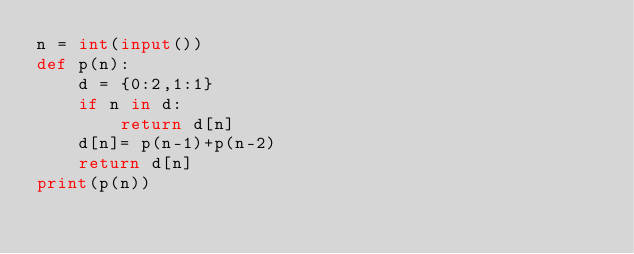Convert code to text. <code><loc_0><loc_0><loc_500><loc_500><_Python_>n = int(input())
def p(n):
    d = {0:2,1:1}
    if n in d:
        return d[n]
    d[n]= p(n-1)+p(n-2)
    return d[n]
print(p(n))</code> 